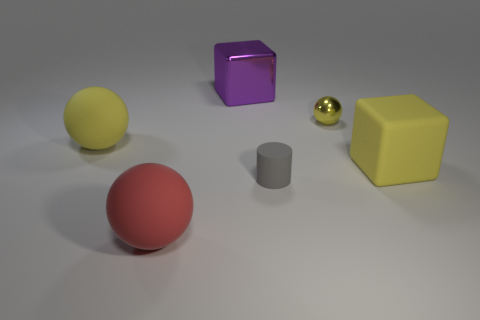Are there any red rubber things of the same shape as the tiny metallic object?
Offer a very short reply. Yes. There is a metal object that is the same size as the red ball; what shape is it?
Offer a very short reply. Cube. What number of things are either rubber objects that are to the left of the big red sphere or small rubber things?
Offer a very short reply. 2. Does the small metal sphere have the same color as the large rubber cube?
Provide a succinct answer. Yes. What is the size of the sphere in front of the big yellow rubber block?
Your response must be concise. Large. Are there any brown rubber things of the same size as the yellow matte cube?
Your response must be concise. No. Is the size of the yellow object right of the yellow shiny thing the same as the large red rubber object?
Keep it short and to the point. Yes. How big is the yellow metal ball?
Keep it short and to the point. Small. What is the color of the large matte ball that is in front of the big yellow rubber object that is behind the large yellow thing that is right of the red thing?
Keep it short and to the point. Red. Is the color of the big rubber thing that is to the right of the red rubber object the same as the big metallic object?
Provide a succinct answer. No. 